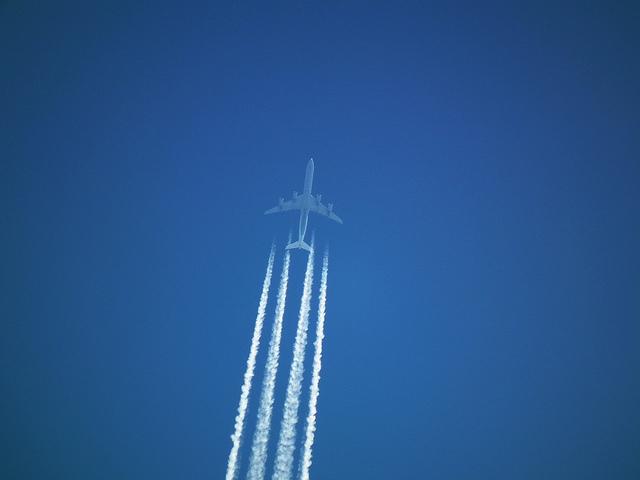Is this a clock tower?
Short answer required. No. How many lines of smoke are trailing the plane?
Write a very short answer. 4. What method of transportation is shown?
Keep it brief. Airplane. How many engines does the plane have?
Quick response, please. 4. Is there a clock in the picture?
Write a very short answer. No. What is this object?
Answer briefly. Plane. 